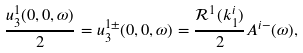Convert formula to latex. <formula><loc_0><loc_0><loc_500><loc_500>\frac { u _ { 3 } ^ { 1 } ( 0 , 0 , \omega ) } { 2 } = u _ { 3 } ^ { 1 \pm } ( 0 , 0 , \omega ) = \frac { \mathcal { R } ^ { 1 } ( k _ { 1 } ^ { i } ) } { 2 } A ^ { i - } ( \omega ) ,</formula> 